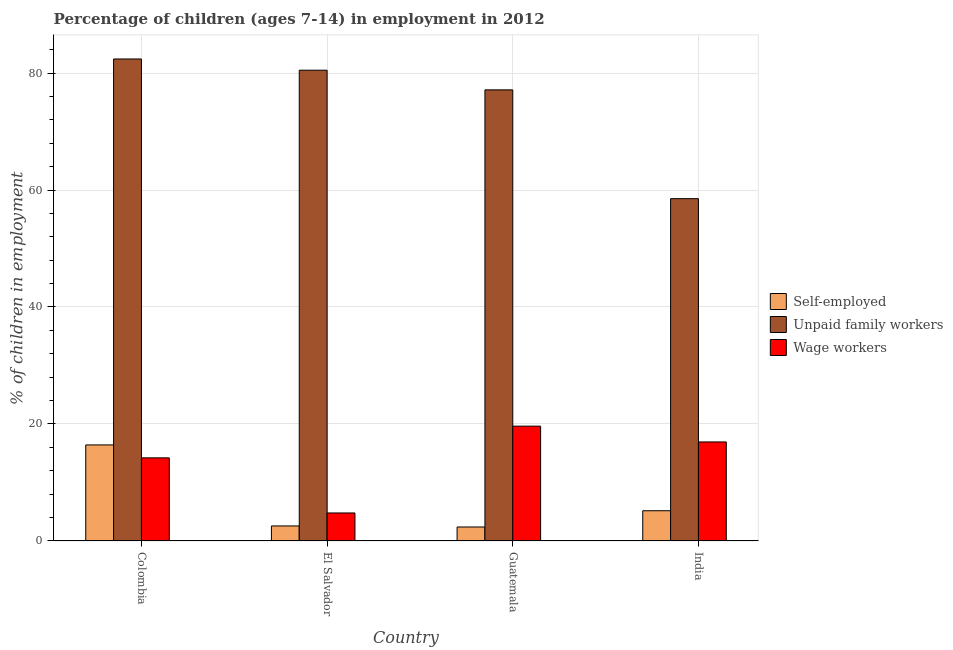Are the number of bars per tick equal to the number of legend labels?
Your response must be concise. Yes. Are the number of bars on each tick of the X-axis equal?
Give a very brief answer. Yes. How many bars are there on the 3rd tick from the left?
Provide a short and direct response. 3. What is the label of the 3rd group of bars from the left?
Offer a very short reply. Guatemala. In how many cases, is the number of bars for a given country not equal to the number of legend labels?
Your answer should be compact. 0. What is the percentage of self employed children in Guatemala?
Make the answer very short. 2.39. Across all countries, what is the maximum percentage of children employed as wage workers?
Provide a short and direct response. 19.63. Across all countries, what is the minimum percentage of self employed children?
Provide a succinct answer. 2.39. What is the total percentage of children employed as wage workers in the graph?
Your answer should be compact. 55.56. What is the difference between the percentage of children employed as wage workers in Colombia and that in El Salvador?
Your answer should be very brief. 9.42. What is the difference between the percentage of children employed as unpaid family workers in India and the percentage of children employed as wage workers in Guatemala?
Make the answer very short. 38.89. What is the average percentage of children employed as unpaid family workers per country?
Offer a terse response. 74.63. What is the difference between the percentage of children employed as wage workers and percentage of children employed as unpaid family workers in Colombia?
Your answer should be very brief. -68.19. What is the ratio of the percentage of self employed children in Guatemala to that in India?
Give a very brief answer. 0.46. Is the percentage of children employed as wage workers in El Salvador less than that in India?
Ensure brevity in your answer.  Yes. What is the difference between the highest and the second highest percentage of self employed children?
Give a very brief answer. 11.25. What is the difference between the highest and the lowest percentage of children employed as unpaid family workers?
Keep it short and to the point. 23.88. In how many countries, is the percentage of children employed as wage workers greater than the average percentage of children employed as wage workers taken over all countries?
Your answer should be very brief. 3. Is the sum of the percentage of self employed children in El Salvador and Guatemala greater than the maximum percentage of children employed as wage workers across all countries?
Ensure brevity in your answer.  No. What does the 3rd bar from the left in Guatemala represents?
Provide a short and direct response. Wage workers. What does the 3rd bar from the right in Guatemala represents?
Your answer should be very brief. Self-employed. Are the values on the major ticks of Y-axis written in scientific E-notation?
Make the answer very short. No. Does the graph contain any zero values?
Your answer should be very brief. No. Does the graph contain grids?
Offer a terse response. Yes. How are the legend labels stacked?
Offer a terse response. Vertical. What is the title of the graph?
Your answer should be very brief. Percentage of children (ages 7-14) in employment in 2012. Does "Taxes on international trade" appear as one of the legend labels in the graph?
Offer a very short reply. No. What is the label or title of the Y-axis?
Offer a very short reply. % of children in employment. What is the % of children in employment of Self-employed in Colombia?
Offer a terse response. 16.42. What is the % of children in employment of Unpaid family workers in Colombia?
Provide a succinct answer. 82.4. What is the % of children in employment in Wage workers in Colombia?
Your answer should be compact. 14.21. What is the % of children in employment of Self-employed in El Salvador?
Your answer should be compact. 2.57. What is the % of children in employment of Unpaid family workers in El Salvador?
Offer a terse response. 80.48. What is the % of children in employment in Wage workers in El Salvador?
Make the answer very short. 4.79. What is the % of children in employment in Self-employed in Guatemala?
Your answer should be compact. 2.39. What is the % of children in employment in Unpaid family workers in Guatemala?
Make the answer very short. 77.12. What is the % of children in employment of Wage workers in Guatemala?
Ensure brevity in your answer.  19.63. What is the % of children in employment of Self-employed in India?
Your answer should be compact. 5.17. What is the % of children in employment of Unpaid family workers in India?
Provide a short and direct response. 58.52. What is the % of children in employment in Wage workers in India?
Make the answer very short. 16.93. Across all countries, what is the maximum % of children in employment of Self-employed?
Keep it short and to the point. 16.42. Across all countries, what is the maximum % of children in employment of Unpaid family workers?
Provide a succinct answer. 82.4. Across all countries, what is the maximum % of children in employment of Wage workers?
Your response must be concise. 19.63. Across all countries, what is the minimum % of children in employment in Self-employed?
Ensure brevity in your answer.  2.39. Across all countries, what is the minimum % of children in employment of Unpaid family workers?
Your response must be concise. 58.52. Across all countries, what is the minimum % of children in employment in Wage workers?
Ensure brevity in your answer.  4.79. What is the total % of children in employment of Self-employed in the graph?
Make the answer very short. 26.55. What is the total % of children in employment of Unpaid family workers in the graph?
Offer a very short reply. 298.52. What is the total % of children in employment in Wage workers in the graph?
Your response must be concise. 55.56. What is the difference between the % of children in employment of Self-employed in Colombia and that in El Salvador?
Offer a terse response. 13.85. What is the difference between the % of children in employment in Unpaid family workers in Colombia and that in El Salvador?
Make the answer very short. 1.92. What is the difference between the % of children in employment in Wage workers in Colombia and that in El Salvador?
Keep it short and to the point. 9.42. What is the difference between the % of children in employment of Self-employed in Colombia and that in Guatemala?
Provide a short and direct response. 14.03. What is the difference between the % of children in employment in Unpaid family workers in Colombia and that in Guatemala?
Offer a terse response. 5.28. What is the difference between the % of children in employment in Wage workers in Colombia and that in Guatemala?
Ensure brevity in your answer.  -5.42. What is the difference between the % of children in employment in Self-employed in Colombia and that in India?
Offer a terse response. 11.25. What is the difference between the % of children in employment of Unpaid family workers in Colombia and that in India?
Give a very brief answer. 23.88. What is the difference between the % of children in employment in Wage workers in Colombia and that in India?
Make the answer very short. -2.72. What is the difference between the % of children in employment of Self-employed in El Salvador and that in Guatemala?
Your answer should be compact. 0.18. What is the difference between the % of children in employment of Unpaid family workers in El Salvador and that in Guatemala?
Your answer should be very brief. 3.36. What is the difference between the % of children in employment of Wage workers in El Salvador and that in Guatemala?
Make the answer very short. -14.84. What is the difference between the % of children in employment of Unpaid family workers in El Salvador and that in India?
Give a very brief answer. 21.96. What is the difference between the % of children in employment in Wage workers in El Salvador and that in India?
Provide a succinct answer. -12.14. What is the difference between the % of children in employment in Self-employed in Guatemala and that in India?
Provide a succinct answer. -2.78. What is the difference between the % of children in employment of Self-employed in Colombia and the % of children in employment of Unpaid family workers in El Salvador?
Your answer should be very brief. -64.06. What is the difference between the % of children in employment in Self-employed in Colombia and the % of children in employment in Wage workers in El Salvador?
Offer a terse response. 11.63. What is the difference between the % of children in employment in Unpaid family workers in Colombia and the % of children in employment in Wage workers in El Salvador?
Your answer should be compact. 77.61. What is the difference between the % of children in employment in Self-employed in Colombia and the % of children in employment in Unpaid family workers in Guatemala?
Provide a succinct answer. -60.7. What is the difference between the % of children in employment of Self-employed in Colombia and the % of children in employment of Wage workers in Guatemala?
Ensure brevity in your answer.  -3.21. What is the difference between the % of children in employment of Unpaid family workers in Colombia and the % of children in employment of Wage workers in Guatemala?
Give a very brief answer. 62.77. What is the difference between the % of children in employment in Self-employed in Colombia and the % of children in employment in Unpaid family workers in India?
Your answer should be compact. -42.1. What is the difference between the % of children in employment in Self-employed in Colombia and the % of children in employment in Wage workers in India?
Your response must be concise. -0.51. What is the difference between the % of children in employment in Unpaid family workers in Colombia and the % of children in employment in Wage workers in India?
Offer a terse response. 65.47. What is the difference between the % of children in employment in Self-employed in El Salvador and the % of children in employment in Unpaid family workers in Guatemala?
Provide a succinct answer. -74.55. What is the difference between the % of children in employment in Self-employed in El Salvador and the % of children in employment in Wage workers in Guatemala?
Keep it short and to the point. -17.06. What is the difference between the % of children in employment of Unpaid family workers in El Salvador and the % of children in employment of Wage workers in Guatemala?
Your answer should be very brief. 60.85. What is the difference between the % of children in employment in Self-employed in El Salvador and the % of children in employment in Unpaid family workers in India?
Make the answer very short. -55.95. What is the difference between the % of children in employment in Self-employed in El Salvador and the % of children in employment in Wage workers in India?
Keep it short and to the point. -14.36. What is the difference between the % of children in employment of Unpaid family workers in El Salvador and the % of children in employment of Wage workers in India?
Ensure brevity in your answer.  63.55. What is the difference between the % of children in employment of Self-employed in Guatemala and the % of children in employment of Unpaid family workers in India?
Offer a terse response. -56.13. What is the difference between the % of children in employment of Self-employed in Guatemala and the % of children in employment of Wage workers in India?
Offer a very short reply. -14.54. What is the difference between the % of children in employment in Unpaid family workers in Guatemala and the % of children in employment in Wage workers in India?
Ensure brevity in your answer.  60.19. What is the average % of children in employment in Self-employed per country?
Keep it short and to the point. 6.64. What is the average % of children in employment in Unpaid family workers per country?
Your answer should be very brief. 74.63. What is the average % of children in employment in Wage workers per country?
Ensure brevity in your answer.  13.89. What is the difference between the % of children in employment of Self-employed and % of children in employment of Unpaid family workers in Colombia?
Provide a short and direct response. -65.98. What is the difference between the % of children in employment in Self-employed and % of children in employment in Wage workers in Colombia?
Your answer should be very brief. 2.21. What is the difference between the % of children in employment in Unpaid family workers and % of children in employment in Wage workers in Colombia?
Ensure brevity in your answer.  68.19. What is the difference between the % of children in employment of Self-employed and % of children in employment of Unpaid family workers in El Salvador?
Make the answer very short. -77.91. What is the difference between the % of children in employment in Self-employed and % of children in employment in Wage workers in El Salvador?
Keep it short and to the point. -2.22. What is the difference between the % of children in employment of Unpaid family workers and % of children in employment of Wage workers in El Salvador?
Make the answer very short. 75.69. What is the difference between the % of children in employment in Self-employed and % of children in employment in Unpaid family workers in Guatemala?
Provide a succinct answer. -74.73. What is the difference between the % of children in employment in Self-employed and % of children in employment in Wage workers in Guatemala?
Give a very brief answer. -17.24. What is the difference between the % of children in employment of Unpaid family workers and % of children in employment of Wage workers in Guatemala?
Make the answer very short. 57.49. What is the difference between the % of children in employment in Self-employed and % of children in employment in Unpaid family workers in India?
Make the answer very short. -53.35. What is the difference between the % of children in employment of Self-employed and % of children in employment of Wage workers in India?
Your response must be concise. -11.76. What is the difference between the % of children in employment in Unpaid family workers and % of children in employment in Wage workers in India?
Provide a succinct answer. 41.59. What is the ratio of the % of children in employment in Self-employed in Colombia to that in El Salvador?
Offer a very short reply. 6.39. What is the ratio of the % of children in employment of Unpaid family workers in Colombia to that in El Salvador?
Offer a very short reply. 1.02. What is the ratio of the % of children in employment of Wage workers in Colombia to that in El Salvador?
Make the answer very short. 2.97. What is the ratio of the % of children in employment in Self-employed in Colombia to that in Guatemala?
Provide a short and direct response. 6.87. What is the ratio of the % of children in employment in Unpaid family workers in Colombia to that in Guatemala?
Your response must be concise. 1.07. What is the ratio of the % of children in employment in Wage workers in Colombia to that in Guatemala?
Keep it short and to the point. 0.72. What is the ratio of the % of children in employment in Self-employed in Colombia to that in India?
Make the answer very short. 3.18. What is the ratio of the % of children in employment of Unpaid family workers in Colombia to that in India?
Provide a succinct answer. 1.41. What is the ratio of the % of children in employment of Wage workers in Colombia to that in India?
Your response must be concise. 0.84. What is the ratio of the % of children in employment of Self-employed in El Salvador to that in Guatemala?
Provide a succinct answer. 1.08. What is the ratio of the % of children in employment of Unpaid family workers in El Salvador to that in Guatemala?
Provide a succinct answer. 1.04. What is the ratio of the % of children in employment of Wage workers in El Salvador to that in Guatemala?
Your answer should be very brief. 0.24. What is the ratio of the % of children in employment of Self-employed in El Salvador to that in India?
Offer a very short reply. 0.5. What is the ratio of the % of children in employment in Unpaid family workers in El Salvador to that in India?
Make the answer very short. 1.38. What is the ratio of the % of children in employment of Wage workers in El Salvador to that in India?
Offer a terse response. 0.28. What is the ratio of the % of children in employment of Self-employed in Guatemala to that in India?
Give a very brief answer. 0.46. What is the ratio of the % of children in employment in Unpaid family workers in Guatemala to that in India?
Offer a terse response. 1.32. What is the ratio of the % of children in employment in Wage workers in Guatemala to that in India?
Your response must be concise. 1.16. What is the difference between the highest and the second highest % of children in employment of Self-employed?
Give a very brief answer. 11.25. What is the difference between the highest and the second highest % of children in employment in Unpaid family workers?
Make the answer very short. 1.92. What is the difference between the highest and the lowest % of children in employment in Self-employed?
Ensure brevity in your answer.  14.03. What is the difference between the highest and the lowest % of children in employment of Unpaid family workers?
Provide a succinct answer. 23.88. What is the difference between the highest and the lowest % of children in employment in Wage workers?
Give a very brief answer. 14.84. 